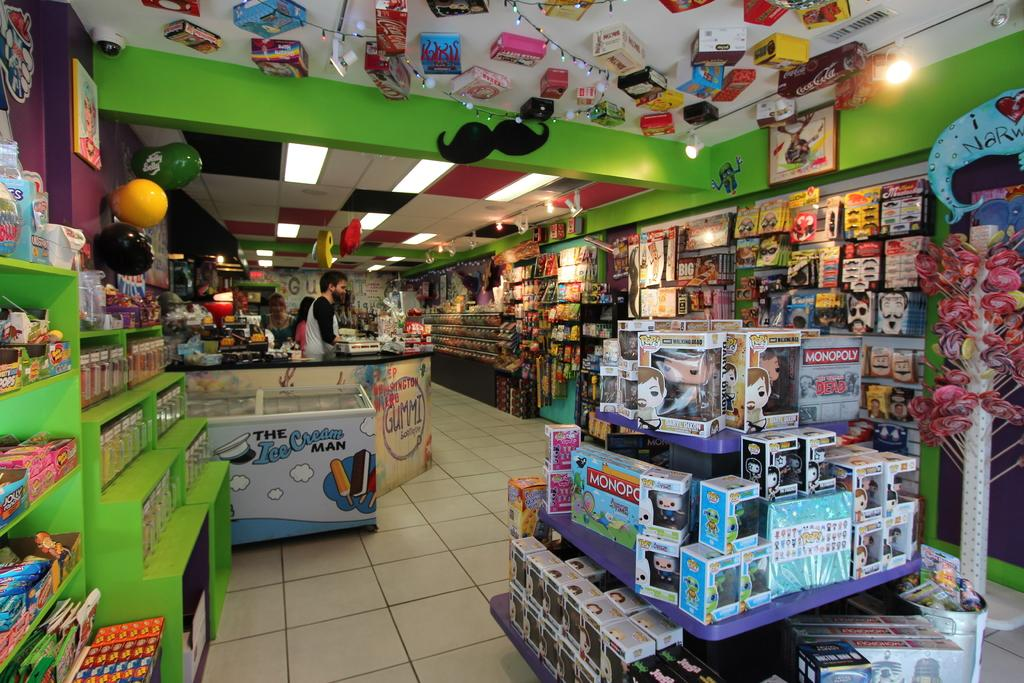Provide a one-sentence caption for the provided image. An inside of a toy store with shelves of toys and a display in the front with various toys including a Monopoly board game. 